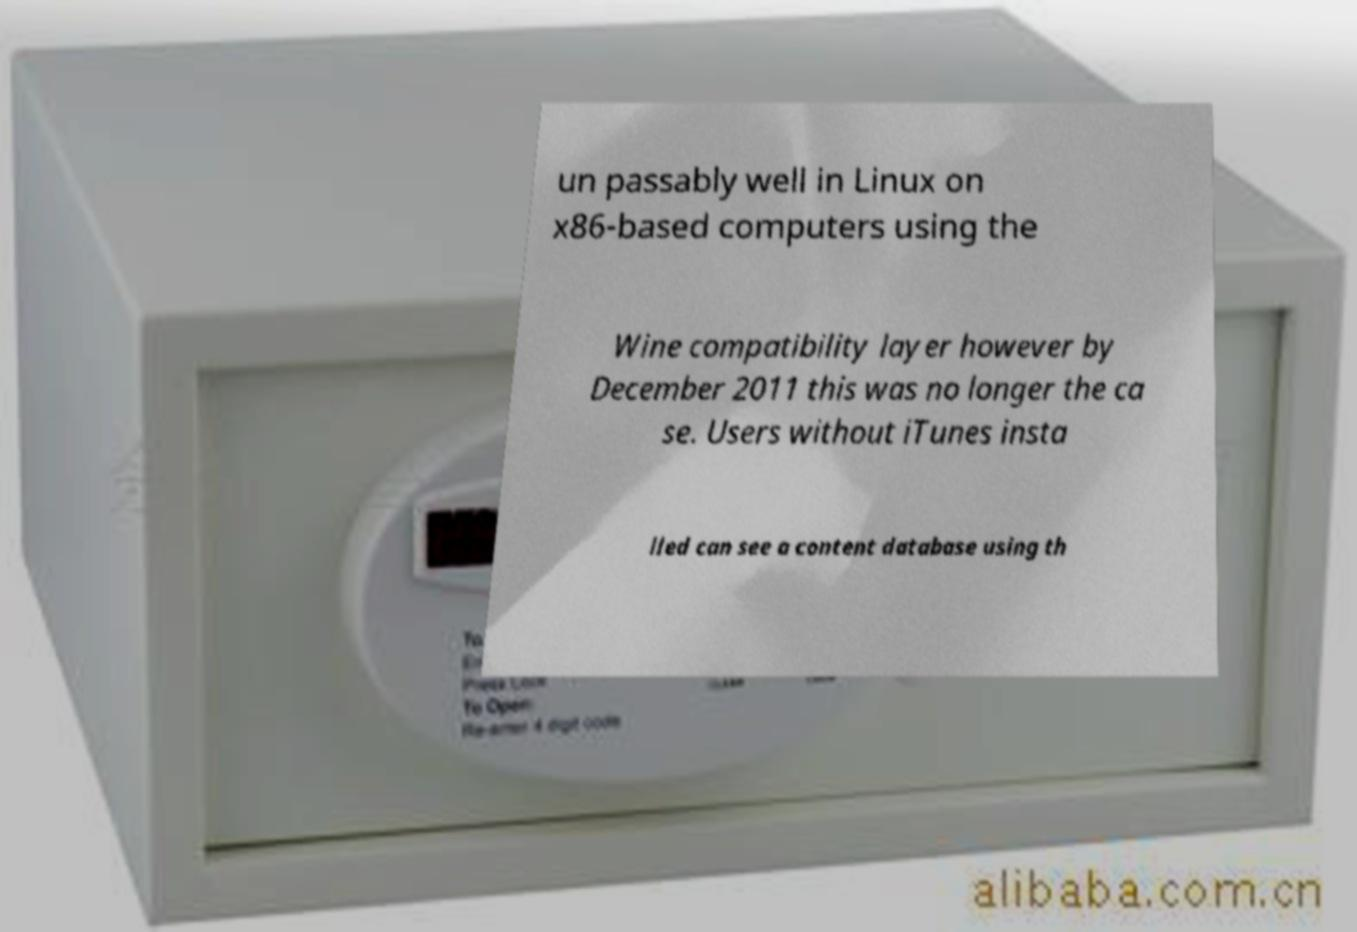For documentation purposes, I need the text within this image transcribed. Could you provide that? un passably well in Linux on x86-based computers using the Wine compatibility layer however by December 2011 this was no longer the ca se. Users without iTunes insta lled can see a content database using th 